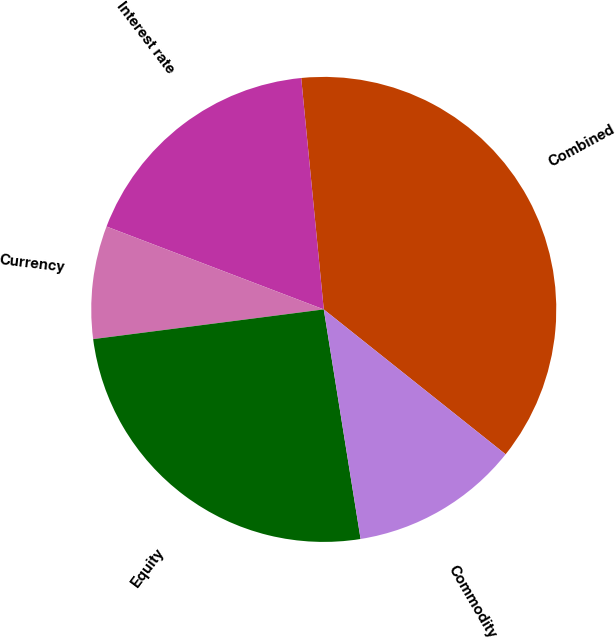Convert chart. <chart><loc_0><loc_0><loc_500><loc_500><pie_chart><fcel>Combined<fcel>Interest rate<fcel>Currency<fcel>Equity<fcel>Commodity<nl><fcel>37.25%<fcel>17.65%<fcel>7.84%<fcel>25.49%<fcel>11.76%<nl></chart> 